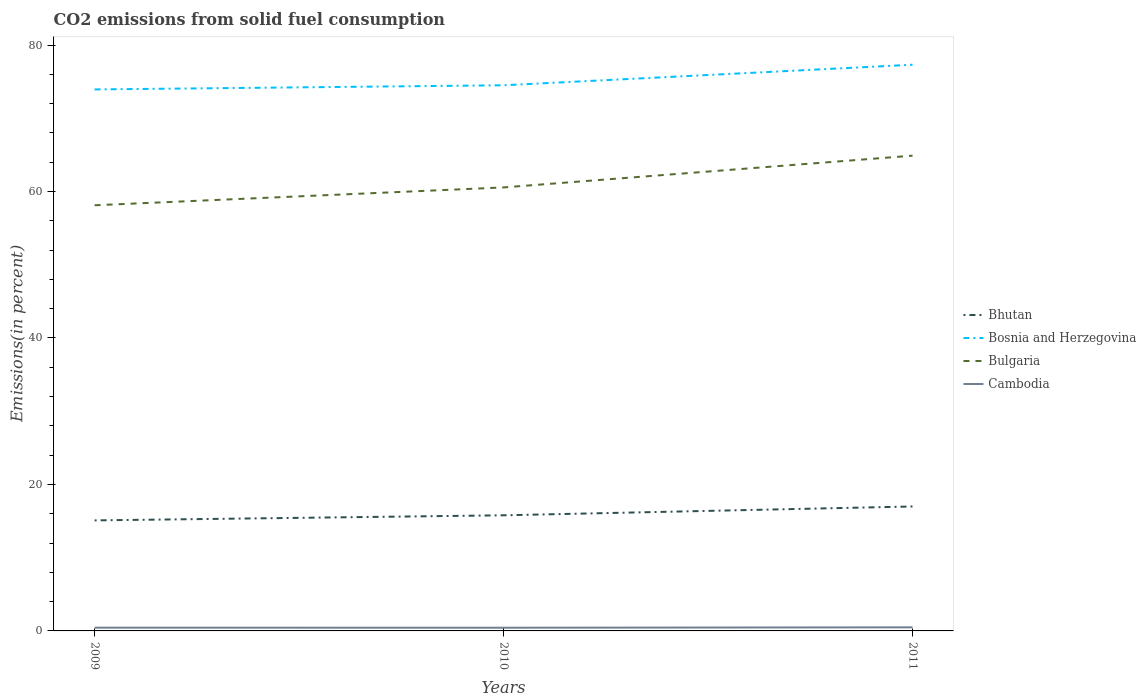How many different coloured lines are there?
Keep it short and to the point. 4. Does the line corresponding to Cambodia intersect with the line corresponding to Bosnia and Herzegovina?
Your response must be concise. No. Across all years, what is the maximum total CO2 emitted in Bulgaria?
Offer a terse response. 58.12. What is the total total CO2 emitted in Cambodia in the graph?
Your response must be concise. 0.01. What is the difference between the highest and the second highest total CO2 emitted in Cambodia?
Ensure brevity in your answer.  0.05. What is the difference between the highest and the lowest total CO2 emitted in Bosnia and Herzegovina?
Provide a succinct answer. 1. Does the graph contain grids?
Offer a terse response. No. What is the title of the graph?
Make the answer very short. CO2 emissions from solid fuel consumption. Does "Haiti" appear as one of the legend labels in the graph?
Your response must be concise. No. What is the label or title of the X-axis?
Make the answer very short. Years. What is the label or title of the Y-axis?
Your answer should be very brief. Emissions(in percent). What is the Emissions(in percent) in Bhutan in 2009?
Ensure brevity in your answer.  15.09. What is the Emissions(in percent) in Bosnia and Herzegovina in 2009?
Keep it short and to the point. 73.94. What is the Emissions(in percent) of Bulgaria in 2009?
Your answer should be very brief. 58.12. What is the Emissions(in percent) in Cambodia in 2009?
Offer a very short reply. 0.44. What is the Emissions(in percent) of Bhutan in 2010?
Your answer should be compact. 15.79. What is the Emissions(in percent) of Bosnia and Herzegovina in 2010?
Your answer should be compact. 74.51. What is the Emissions(in percent) in Bulgaria in 2010?
Provide a short and direct response. 60.56. What is the Emissions(in percent) of Cambodia in 2010?
Offer a very short reply. 0.44. What is the Emissions(in percent) of Bhutan in 2011?
Give a very brief answer. 16.99. What is the Emissions(in percent) of Bosnia and Herzegovina in 2011?
Your response must be concise. 77.32. What is the Emissions(in percent) in Bulgaria in 2011?
Offer a very short reply. 64.9. What is the Emissions(in percent) in Cambodia in 2011?
Give a very brief answer. 0.49. Across all years, what is the maximum Emissions(in percent) of Bhutan?
Keep it short and to the point. 16.99. Across all years, what is the maximum Emissions(in percent) in Bosnia and Herzegovina?
Offer a very short reply. 77.32. Across all years, what is the maximum Emissions(in percent) in Bulgaria?
Make the answer very short. 64.9. Across all years, what is the maximum Emissions(in percent) of Cambodia?
Provide a short and direct response. 0.49. Across all years, what is the minimum Emissions(in percent) of Bhutan?
Keep it short and to the point. 15.09. Across all years, what is the minimum Emissions(in percent) of Bosnia and Herzegovina?
Ensure brevity in your answer.  73.94. Across all years, what is the minimum Emissions(in percent) of Bulgaria?
Offer a terse response. 58.12. Across all years, what is the minimum Emissions(in percent) in Cambodia?
Your response must be concise. 0.44. What is the total Emissions(in percent) in Bhutan in the graph?
Give a very brief answer. 47.88. What is the total Emissions(in percent) in Bosnia and Herzegovina in the graph?
Offer a very short reply. 225.77. What is the total Emissions(in percent) in Bulgaria in the graph?
Give a very brief answer. 183.58. What is the total Emissions(in percent) in Cambodia in the graph?
Offer a very short reply. 1.37. What is the difference between the Emissions(in percent) in Bhutan in 2009 and that in 2010?
Ensure brevity in your answer.  -0.7. What is the difference between the Emissions(in percent) of Bosnia and Herzegovina in 2009 and that in 2010?
Give a very brief answer. -0.57. What is the difference between the Emissions(in percent) in Bulgaria in 2009 and that in 2010?
Your response must be concise. -2.44. What is the difference between the Emissions(in percent) in Cambodia in 2009 and that in 2010?
Keep it short and to the point. 0.01. What is the difference between the Emissions(in percent) in Bhutan in 2009 and that in 2011?
Give a very brief answer. -1.9. What is the difference between the Emissions(in percent) in Bosnia and Herzegovina in 2009 and that in 2011?
Your answer should be very brief. -3.37. What is the difference between the Emissions(in percent) in Bulgaria in 2009 and that in 2011?
Your answer should be compact. -6.77. What is the difference between the Emissions(in percent) in Cambodia in 2009 and that in 2011?
Give a very brief answer. -0.05. What is the difference between the Emissions(in percent) in Bhutan in 2010 and that in 2011?
Provide a succinct answer. -1.2. What is the difference between the Emissions(in percent) in Bosnia and Herzegovina in 2010 and that in 2011?
Offer a very short reply. -2.81. What is the difference between the Emissions(in percent) in Bulgaria in 2010 and that in 2011?
Ensure brevity in your answer.  -4.34. What is the difference between the Emissions(in percent) of Cambodia in 2010 and that in 2011?
Provide a short and direct response. -0.05. What is the difference between the Emissions(in percent) of Bhutan in 2009 and the Emissions(in percent) of Bosnia and Herzegovina in 2010?
Make the answer very short. -59.42. What is the difference between the Emissions(in percent) of Bhutan in 2009 and the Emissions(in percent) of Bulgaria in 2010?
Offer a very short reply. -45.47. What is the difference between the Emissions(in percent) of Bhutan in 2009 and the Emissions(in percent) of Cambodia in 2010?
Your response must be concise. 14.66. What is the difference between the Emissions(in percent) in Bosnia and Herzegovina in 2009 and the Emissions(in percent) in Bulgaria in 2010?
Offer a very short reply. 13.38. What is the difference between the Emissions(in percent) of Bosnia and Herzegovina in 2009 and the Emissions(in percent) of Cambodia in 2010?
Your answer should be compact. 73.5. What is the difference between the Emissions(in percent) in Bulgaria in 2009 and the Emissions(in percent) in Cambodia in 2010?
Your response must be concise. 57.69. What is the difference between the Emissions(in percent) of Bhutan in 2009 and the Emissions(in percent) of Bosnia and Herzegovina in 2011?
Give a very brief answer. -62.22. What is the difference between the Emissions(in percent) of Bhutan in 2009 and the Emissions(in percent) of Bulgaria in 2011?
Provide a succinct answer. -49.8. What is the difference between the Emissions(in percent) in Bhutan in 2009 and the Emissions(in percent) in Cambodia in 2011?
Make the answer very short. 14.6. What is the difference between the Emissions(in percent) in Bosnia and Herzegovina in 2009 and the Emissions(in percent) in Bulgaria in 2011?
Your answer should be compact. 9.04. What is the difference between the Emissions(in percent) of Bosnia and Herzegovina in 2009 and the Emissions(in percent) of Cambodia in 2011?
Provide a short and direct response. 73.45. What is the difference between the Emissions(in percent) of Bulgaria in 2009 and the Emissions(in percent) of Cambodia in 2011?
Provide a short and direct response. 57.63. What is the difference between the Emissions(in percent) of Bhutan in 2010 and the Emissions(in percent) of Bosnia and Herzegovina in 2011?
Your answer should be compact. -61.53. What is the difference between the Emissions(in percent) in Bhutan in 2010 and the Emissions(in percent) in Bulgaria in 2011?
Your answer should be very brief. -49.11. What is the difference between the Emissions(in percent) in Bhutan in 2010 and the Emissions(in percent) in Cambodia in 2011?
Give a very brief answer. 15.3. What is the difference between the Emissions(in percent) in Bosnia and Herzegovina in 2010 and the Emissions(in percent) in Bulgaria in 2011?
Provide a short and direct response. 9.61. What is the difference between the Emissions(in percent) of Bosnia and Herzegovina in 2010 and the Emissions(in percent) of Cambodia in 2011?
Offer a terse response. 74.02. What is the difference between the Emissions(in percent) in Bulgaria in 2010 and the Emissions(in percent) in Cambodia in 2011?
Keep it short and to the point. 60.07. What is the average Emissions(in percent) of Bhutan per year?
Your response must be concise. 15.96. What is the average Emissions(in percent) of Bosnia and Herzegovina per year?
Provide a succinct answer. 75.26. What is the average Emissions(in percent) of Bulgaria per year?
Give a very brief answer. 61.19. What is the average Emissions(in percent) of Cambodia per year?
Your response must be concise. 0.46. In the year 2009, what is the difference between the Emissions(in percent) of Bhutan and Emissions(in percent) of Bosnia and Herzegovina?
Give a very brief answer. -58.85. In the year 2009, what is the difference between the Emissions(in percent) in Bhutan and Emissions(in percent) in Bulgaria?
Offer a very short reply. -43.03. In the year 2009, what is the difference between the Emissions(in percent) of Bhutan and Emissions(in percent) of Cambodia?
Offer a terse response. 14.65. In the year 2009, what is the difference between the Emissions(in percent) in Bosnia and Herzegovina and Emissions(in percent) in Bulgaria?
Provide a short and direct response. 15.82. In the year 2009, what is the difference between the Emissions(in percent) in Bosnia and Herzegovina and Emissions(in percent) in Cambodia?
Your response must be concise. 73.5. In the year 2009, what is the difference between the Emissions(in percent) of Bulgaria and Emissions(in percent) of Cambodia?
Your answer should be compact. 57.68. In the year 2010, what is the difference between the Emissions(in percent) of Bhutan and Emissions(in percent) of Bosnia and Herzegovina?
Offer a very short reply. -58.72. In the year 2010, what is the difference between the Emissions(in percent) in Bhutan and Emissions(in percent) in Bulgaria?
Your response must be concise. -44.77. In the year 2010, what is the difference between the Emissions(in percent) in Bhutan and Emissions(in percent) in Cambodia?
Provide a short and direct response. 15.35. In the year 2010, what is the difference between the Emissions(in percent) in Bosnia and Herzegovina and Emissions(in percent) in Bulgaria?
Your answer should be very brief. 13.95. In the year 2010, what is the difference between the Emissions(in percent) of Bosnia and Herzegovina and Emissions(in percent) of Cambodia?
Offer a very short reply. 74.07. In the year 2010, what is the difference between the Emissions(in percent) in Bulgaria and Emissions(in percent) in Cambodia?
Your answer should be very brief. 60.12. In the year 2011, what is the difference between the Emissions(in percent) of Bhutan and Emissions(in percent) of Bosnia and Herzegovina?
Give a very brief answer. -60.32. In the year 2011, what is the difference between the Emissions(in percent) of Bhutan and Emissions(in percent) of Bulgaria?
Your answer should be compact. -47.9. In the year 2011, what is the difference between the Emissions(in percent) of Bhutan and Emissions(in percent) of Cambodia?
Your answer should be very brief. 16.5. In the year 2011, what is the difference between the Emissions(in percent) in Bosnia and Herzegovina and Emissions(in percent) in Bulgaria?
Offer a terse response. 12.42. In the year 2011, what is the difference between the Emissions(in percent) in Bosnia and Herzegovina and Emissions(in percent) in Cambodia?
Your response must be concise. 76.83. In the year 2011, what is the difference between the Emissions(in percent) in Bulgaria and Emissions(in percent) in Cambodia?
Keep it short and to the point. 64.41. What is the ratio of the Emissions(in percent) in Bhutan in 2009 to that in 2010?
Your answer should be compact. 0.96. What is the ratio of the Emissions(in percent) of Bosnia and Herzegovina in 2009 to that in 2010?
Offer a very short reply. 0.99. What is the ratio of the Emissions(in percent) of Bulgaria in 2009 to that in 2010?
Your answer should be very brief. 0.96. What is the ratio of the Emissions(in percent) in Cambodia in 2009 to that in 2010?
Make the answer very short. 1.01. What is the ratio of the Emissions(in percent) of Bhutan in 2009 to that in 2011?
Keep it short and to the point. 0.89. What is the ratio of the Emissions(in percent) in Bosnia and Herzegovina in 2009 to that in 2011?
Your answer should be compact. 0.96. What is the ratio of the Emissions(in percent) in Bulgaria in 2009 to that in 2011?
Make the answer very short. 0.9. What is the ratio of the Emissions(in percent) in Cambodia in 2009 to that in 2011?
Your answer should be very brief. 0.91. What is the ratio of the Emissions(in percent) of Bhutan in 2010 to that in 2011?
Your answer should be compact. 0.93. What is the ratio of the Emissions(in percent) of Bosnia and Herzegovina in 2010 to that in 2011?
Offer a terse response. 0.96. What is the ratio of the Emissions(in percent) of Bulgaria in 2010 to that in 2011?
Your answer should be compact. 0.93. What is the ratio of the Emissions(in percent) in Cambodia in 2010 to that in 2011?
Your answer should be very brief. 0.89. What is the difference between the highest and the second highest Emissions(in percent) of Bhutan?
Your answer should be compact. 1.2. What is the difference between the highest and the second highest Emissions(in percent) in Bosnia and Herzegovina?
Keep it short and to the point. 2.81. What is the difference between the highest and the second highest Emissions(in percent) in Bulgaria?
Ensure brevity in your answer.  4.34. What is the difference between the highest and the second highest Emissions(in percent) in Cambodia?
Provide a short and direct response. 0.05. What is the difference between the highest and the lowest Emissions(in percent) of Bhutan?
Offer a terse response. 1.9. What is the difference between the highest and the lowest Emissions(in percent) of Bosnia and Herzegovina?
Your response must be concise. 3.37. What is the difference between the highest and the lowest Emissions(in percent) of Bulgaria?
Offer a terse response. 6.77. What is the difference between the highest and the lowest Emissions(in percent) of Cambodia?
Offer a very short reply. 0.05. 